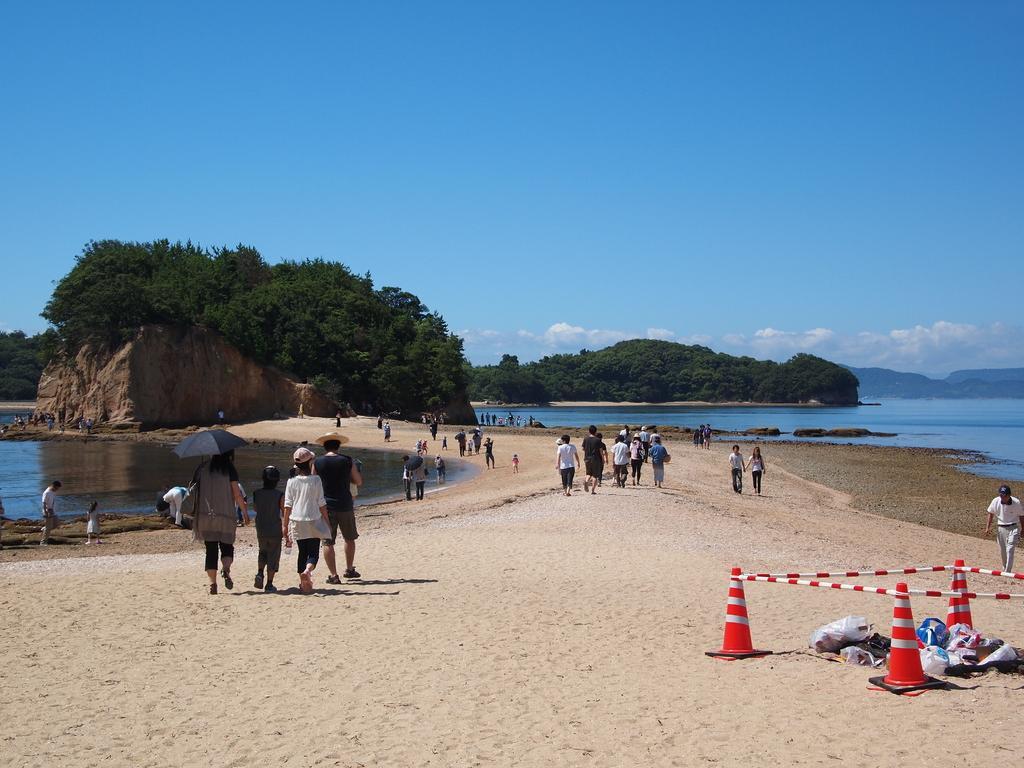Could you give a brief overview of what you see in this image? In the picture we can see a sand surface on it, we can see many people are walking and on the both the sides of the surface, we can see water surface and on the sand, we can see a huge rock with trees on it and in the background also we can see many trees and the sky with clouds. 